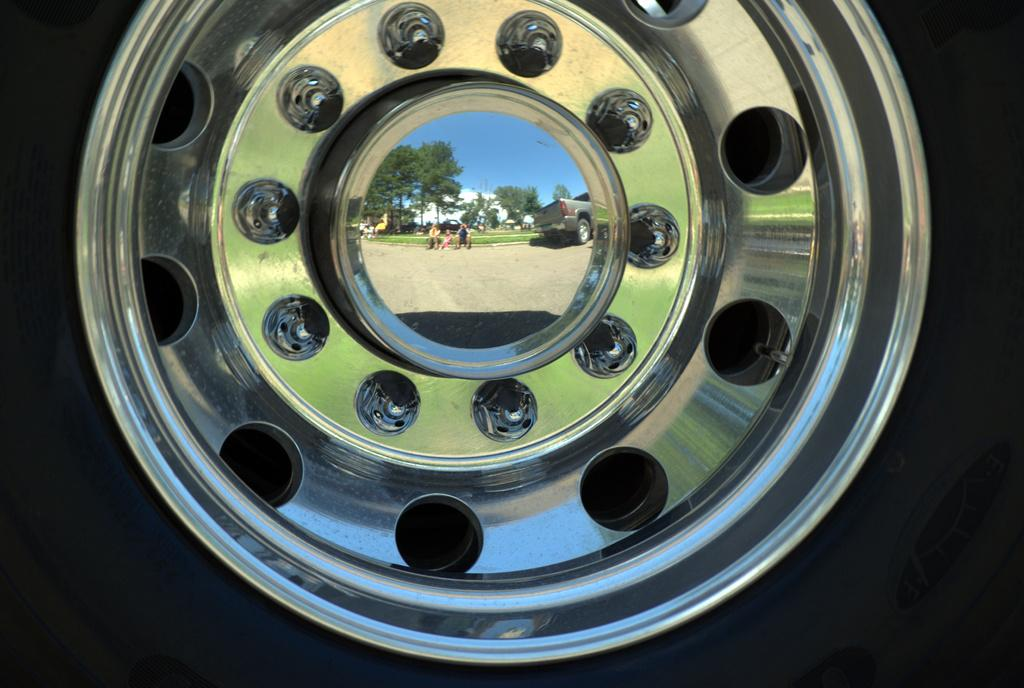What is the main object in the image? There is a car rim wheel in the image. What can be seen on the surface of the car rim wheel? The reflection of some persons sitting on the ground is visible on the car rim wheel. What is happening in the background of the image? A vehicle is moving in the image. What type of natural environment is visible in the image? There are trees in the image. How would you describe the weather based on the image? The sky is clear in the image, suggesting good weather. What type of pain is the car rim wheel experiencing in the image? The car rim wheel is not experiencing any pain, as it is an inanimate object. 